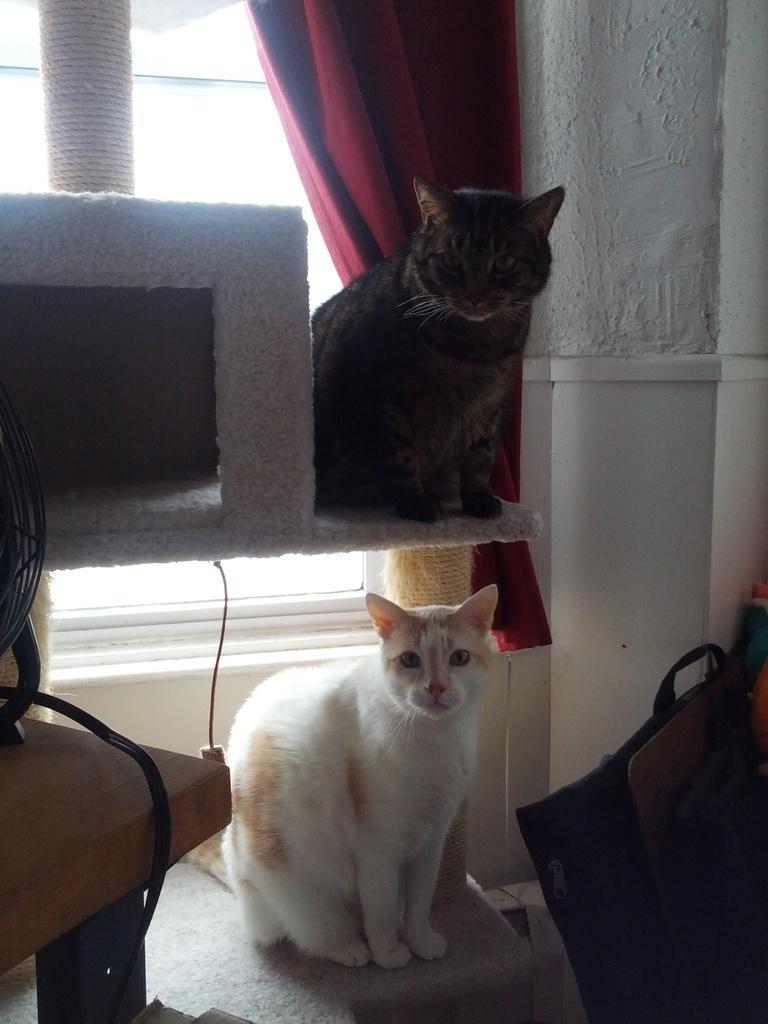How would you summarize this image in a sentence or two? 2 cats are present. on the top there is a black cat , below that there is a white cat. on the left, at the table there is a fan. behind the cats there is ar ed curtain. right to that there is a white wall. 